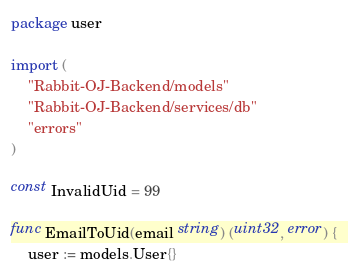<code> <loc_0><loc_0><loc_500><loc_500><_Go_>package user

import (
	"Rabbit-OJ-Backend/models"
	"Rabbit-OJ-Backend/services/db"
	"errors"
)

const InvalidUid = 99

func EmailToUid(email string) (uint32, error) {
	user := models.User{}
</code> 